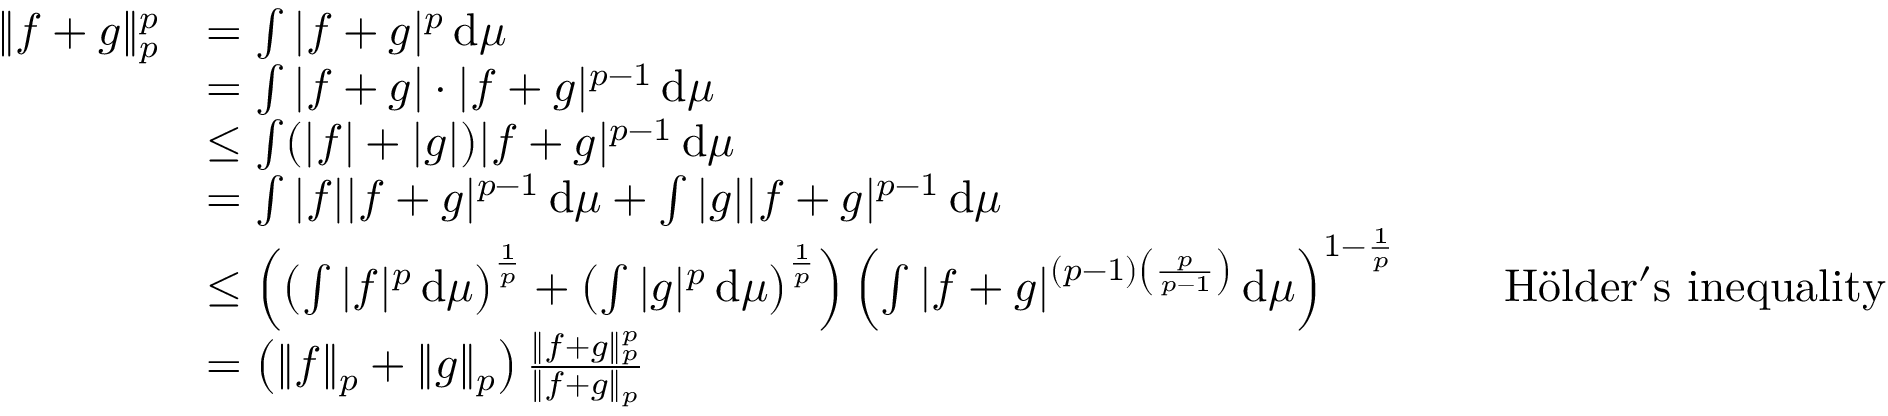Convert formula to latex. <formula><loc_0><loc_0><loc_500><loc_500>{ \begin{array} { r l r l } { \| f + g \| _ { p } ^ { p } } & { = \int | f + g | ^ { p } \, d \mu } \\ & { = \int | f + g | \cdot | f + g | ^ { p - 1 } \, d \mu } \\ & { \leq \int ( | f | + | g | ) | f + g | ^ { p - 1 } \, d \mu } \\ & { = \int | f | | f + g | ^ { p - 1 } \, d \mu + \int | g | | f + g | ^ { p - 1 } \, d \mu } \\ & { \leq \left ( \left ( \int | f | ^ { p } \, d \mu \right ) ^ { \frac { 1 } { p } } + \left ( \int | g | ^ { p } \, d \mu \right ) ^ { \frac { 1 } { p } } \right ) \left ( \int | f + g | ^ { ( p - 1 ) \left ( { \frac { p } { p - 1 } } \right ) } \, d \mu \right ) ^ { 1 - { \frac { 1 } { p } } } } & & { H l d e r ^ { \prime } s i n e q u a l i t y } \\ & { = \left ( \| f \| _ { p } + \| g \| _ { p } \right ) { \frac { \| f + g \| _ { p } ^ { p } } { \| f + g \| _ { p } } } } \end{array} }</formula> 